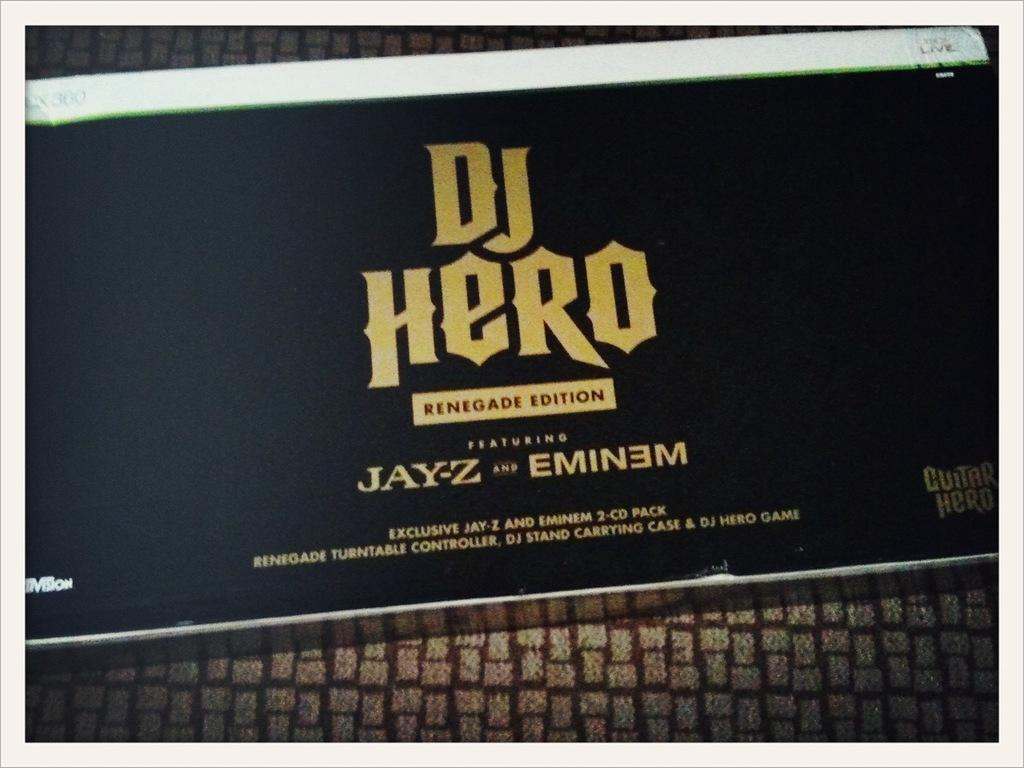<image>
Offer a succinct explanation of the picture presented. Box for a video game that is named DJ Hero. 